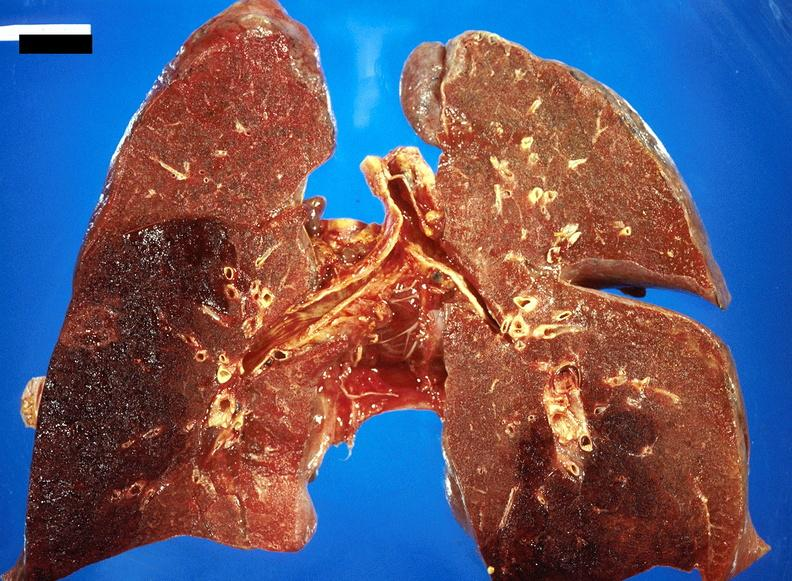what is present?
Answer the question using a single word or phrase. Respiratory 